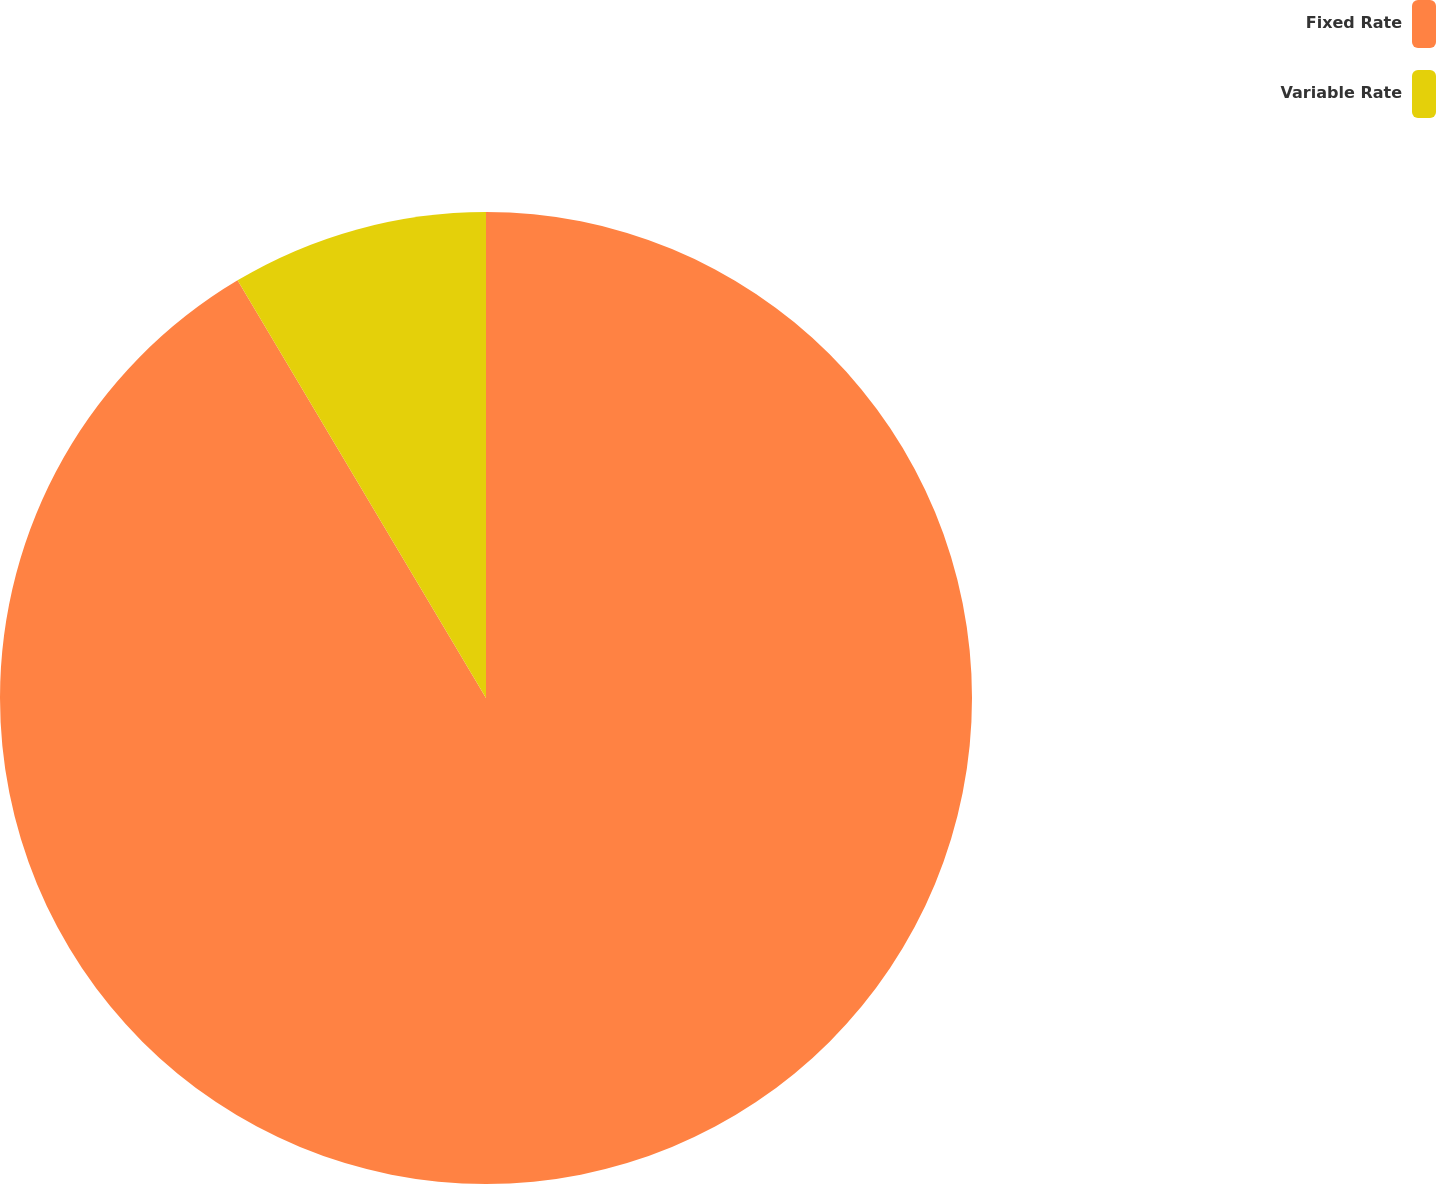<chart> <loc_0><loc_0><loc_500><loc_500><pie_chart><fcel>Fixed Rate<fcel>Variable Rate<nl><fcel>91.46%<fcel>8.54%<nl></chart> 